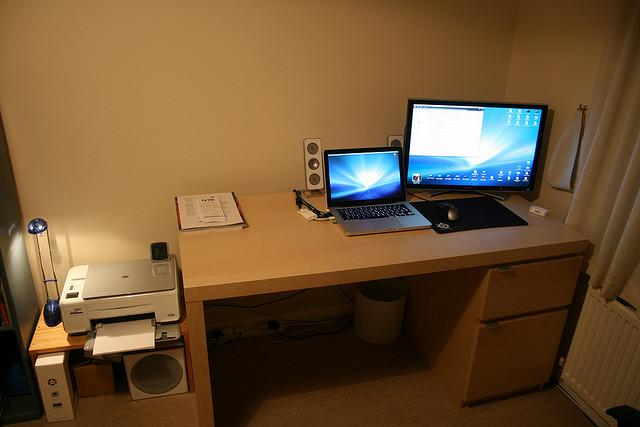What is this desk made of? wood 